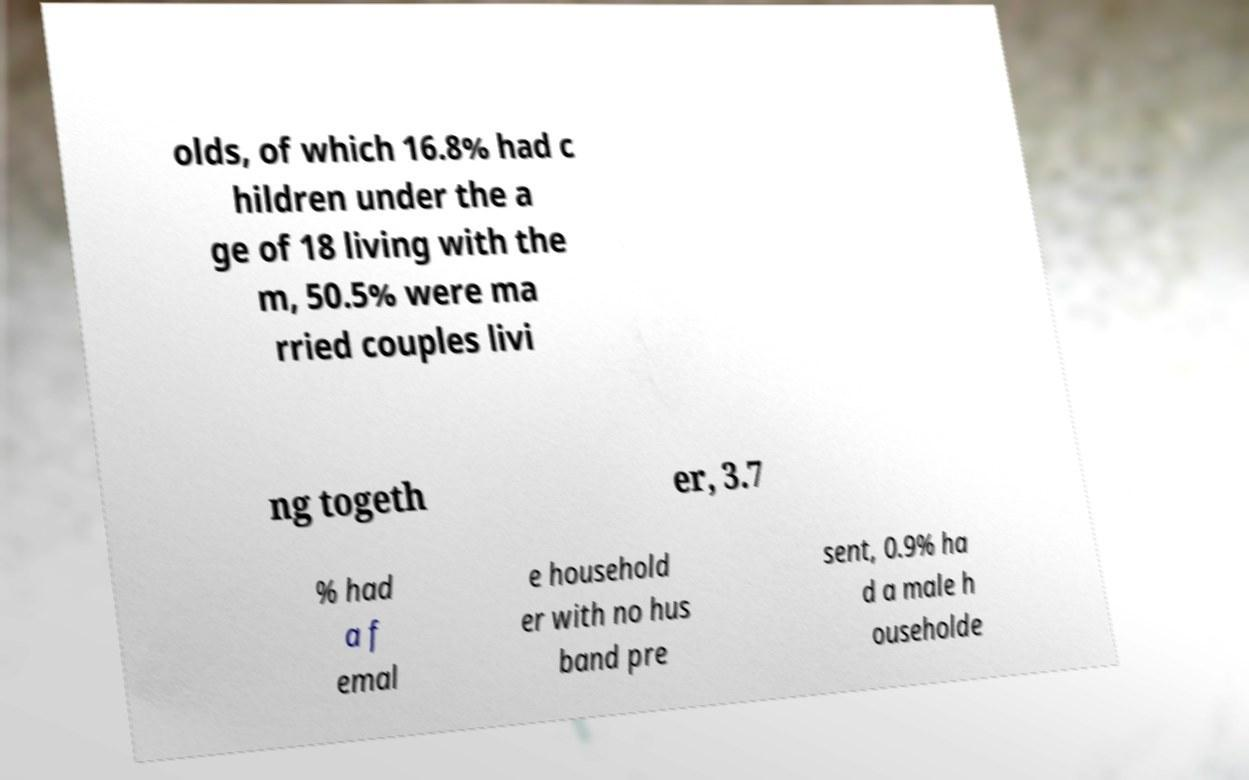Could you assist in decoding the text presented in this image and type it out clearly? olds, of which 16.8% had c hildren under the a ge of 18 living with the m, 50.5% were ma rried couples livi ng togeth er, 3.7 % had a f emal e household er with no hus band pre sent, 0.9% ha d a male h ouseholde 